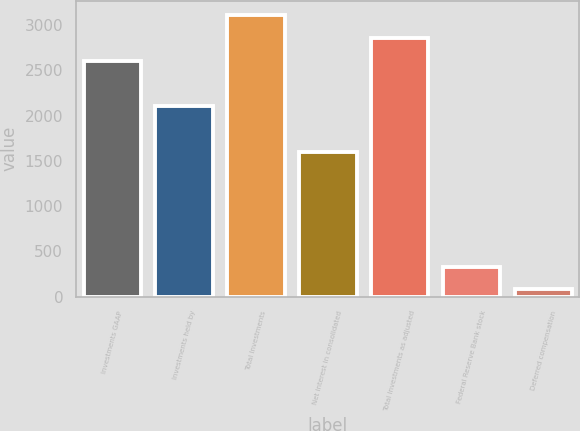Convert chart. <chart><loc_0><loc_0><loc_500><loc_500><bar_chart><fcel>Investments GAAP<fcel>Investments held by<fcel>Total Investments<fcel>Net interest in consolidated<fcel>Total Investments as adjusted<fcel>Federal Reserve Bank stock<fcel>Deferred compensation<nl><fcel>2608<fcel>2102.2<fcel>3113.8<fcel>1596.4<fcel>2860.9<fcel>331.9<fcel>79<nl></chart> 